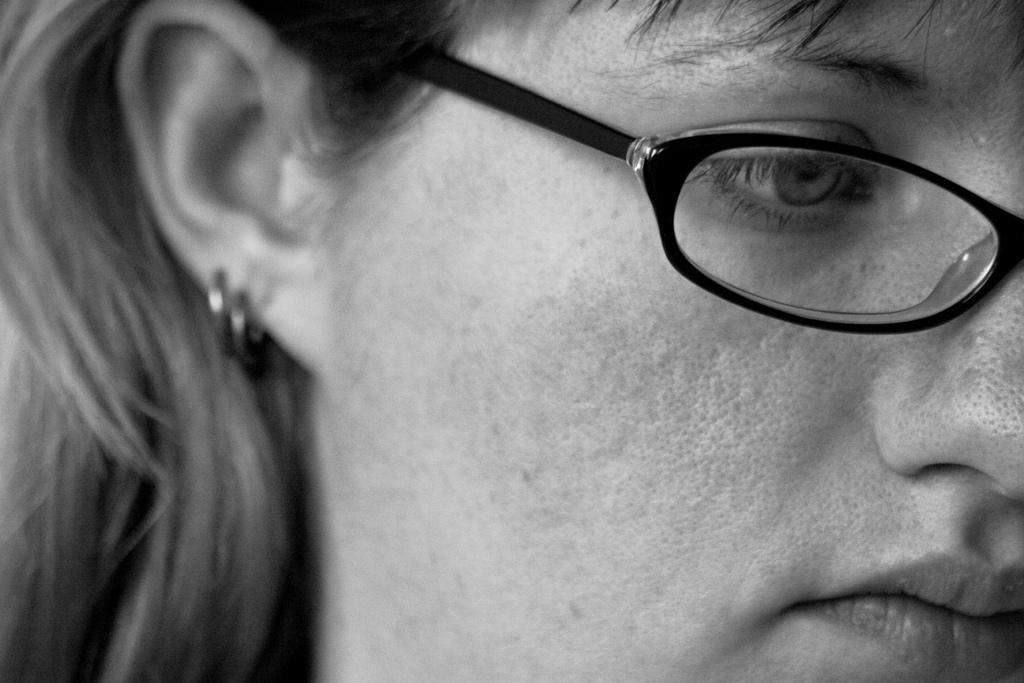What is the main subject of the image? The main subject of the image is a woman's face. What can be seen on the woman's face in the image? The woman is wearing spectacles in the image. What type of sun can be seen in the woman's hair in the image? There is no sun present in the image, and the woman's hair does not contain any sun-like objects. 